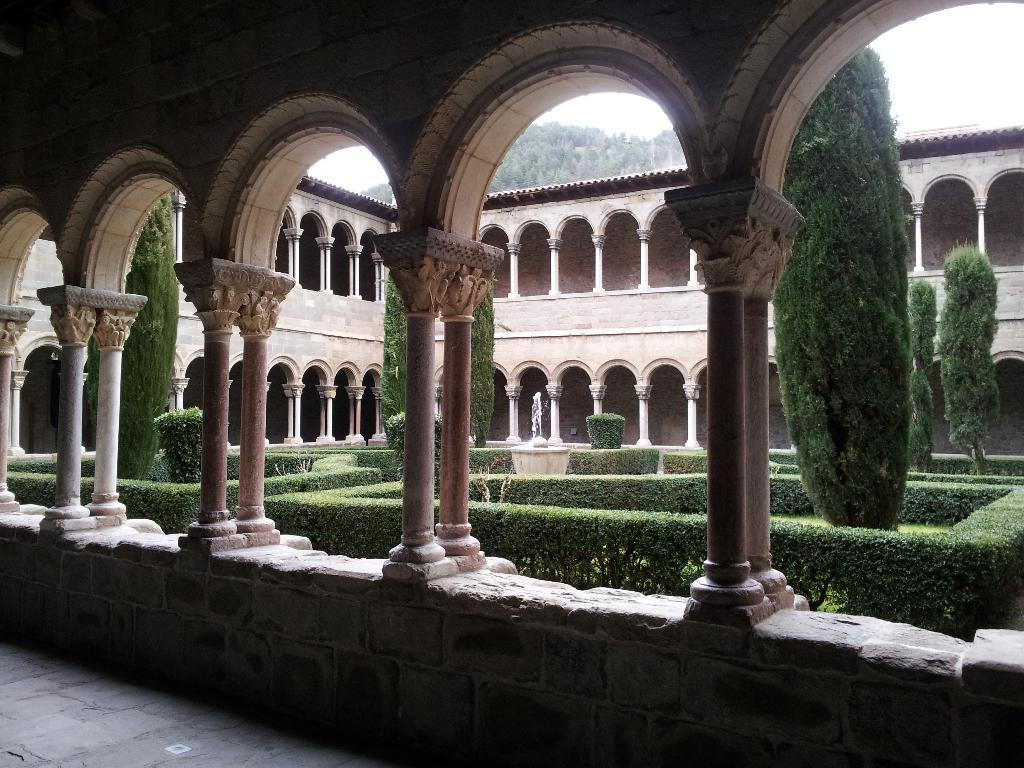What is the main element in the center of the image? There is a sky in the center of the image. What can be seen in the sky? Clouds are visible in the image. What type of natural elements are present in the image? Trees, plants, and grass are visible in the image. What type of man-made structures are present in the image? Buildings, pillars, a roof, and a wall are visible in the image. What type of water feature is in the image? There is a fountain in the image. What level of experience does the maid have in the image? There is no maid present in the image. How does the image depict the expansion of the building? The image does not depict the expansion of the building; it shows the building as it currently exists. 